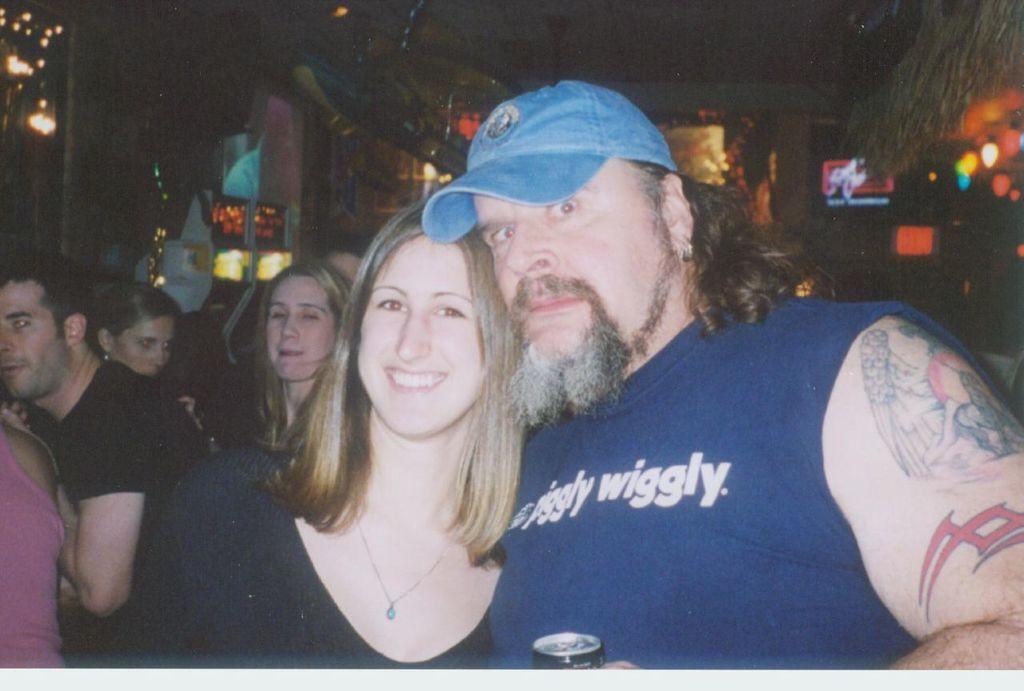Can you describe this image briefly? On the right side of the image we can see a man is standing and holding a tin and wearing a cap. In the center of the image we can see a lady is standing and smiling. In the background of the image we can see a group of people, lights, wall, boards. At the top of the image we can see the roof. 